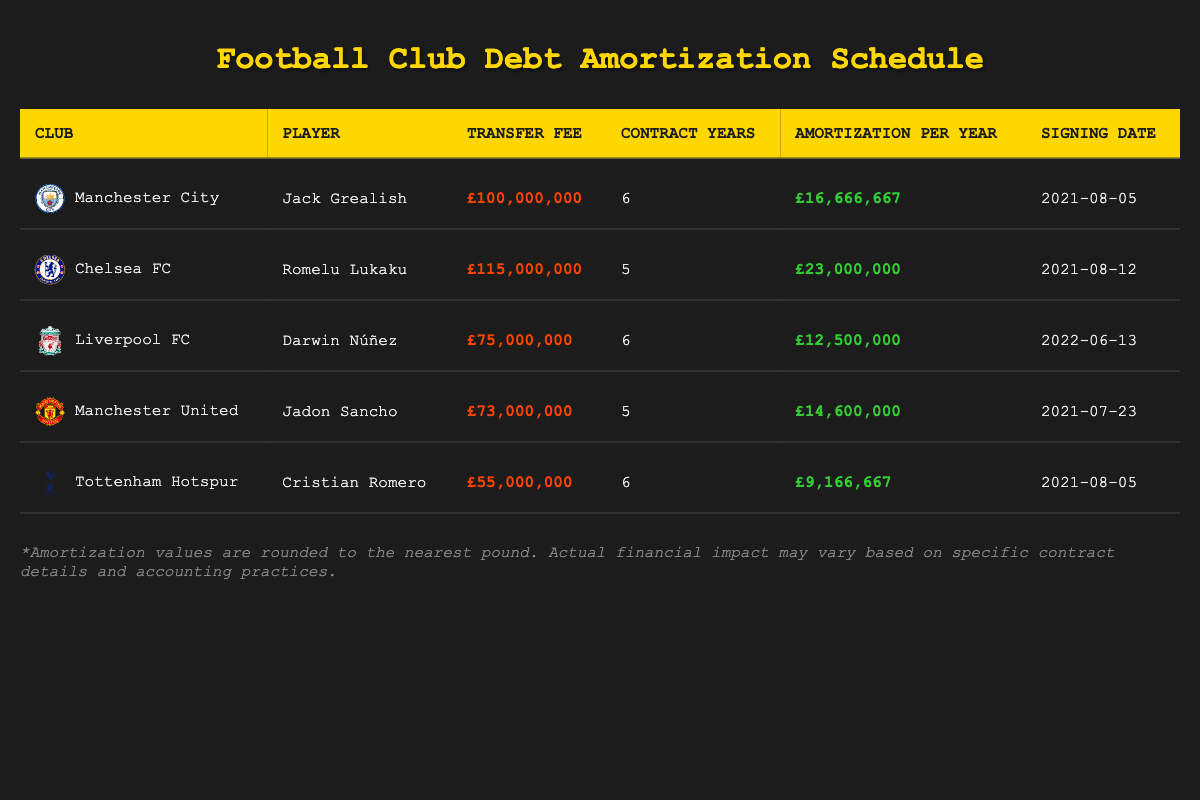What is the transfer fee for Romelu Lukaku? The transfer fee is explicitly stated in the table under the "Transfer Fee" column for Chelsea FC, where Romelu Lukaku is listed. It shows £115,000,000.
Answer: £115,000,000 How many years is Darwin Núñez's contract? The contract duration for Darwin Núñez is found in the "Contract Years" column in the row for Liverpool FC, which indicates a contract length of 6 years.
Answer: 6 years Which player has the highest amortization per year? To find the maximum amortization per year, we compare the "Amortization Per Year" values. Romelu Lukaku has an annual amortization of £23,000,000, which is higher than the others listed.
Answer: Romelu Lukaku What is the total transfer fee for Manchester City and Tottenham Hotspur combined? We sum the transfer fees from the respective rows: Manchester City's fee for Jack Grealish is £100,000,000, and Tottenham's fee for Cristian Romero is £55,000,000. The calculation is £100,000,000 + £55,000,000 = £155,000,000.
Answer: £155,000,000 Is the amortization per year for Jadon Sancho greater than that for Cristian Romero? We check the values in the "Amortization Per Year" column: Jadon Sancho has £14,600,000 while Cristian Romero has £9,166,667. Since £14,600,000 is greater than £9,166,667, the answer is yes.
Answer: Yes What percentage of the total transfer fees listed does Lionel Núñez represent? First, we need to calculate the total transfer fees from all players: £100,000,000 + £115,000,000 + £75,000,000 + £73,000,000 + £55,000,000 = £418,000,000. Darwin Núñez's fee is £75,000,000. The percentage is calculated as (£75,000,000 / £418,000,000) * 100, which equals approximately 17.95%.
Answer: 17.95% Which club has the lowest amortization per year? We list the "Amortization Per Year" figures for all players: Jack Grealish (£16,666,667), Romelu Lukaku (£23,000,000), Darwin Núñez (£12,500,000), Jadon Sancho (£14,600,000), Cristian Romero (£9,166,667). The lowest value is for Cristian Romero at £9,166,667.
Answer: Cristian Romero Is the signing date for Jadon Sancho earlier than that for Jack Grealish? Comparing the signing dates in the "Signing Date" column: Jadon Sancho was signed on 2021-07-23 and Jack Grealish on 2021-08-05. Since July 23 is earlier than August 5, the answer is yes.
Answer: Yes How many players have an annual amortization greater than £15,000,000? From the "Amortization Per Year" column, players with values over £15,000,000 are Romelu Lukaku (£23,000,000) and Jack Grealish (£16,666,667). Thus, there are 2 players fitting this criterion.
Answer: 2 